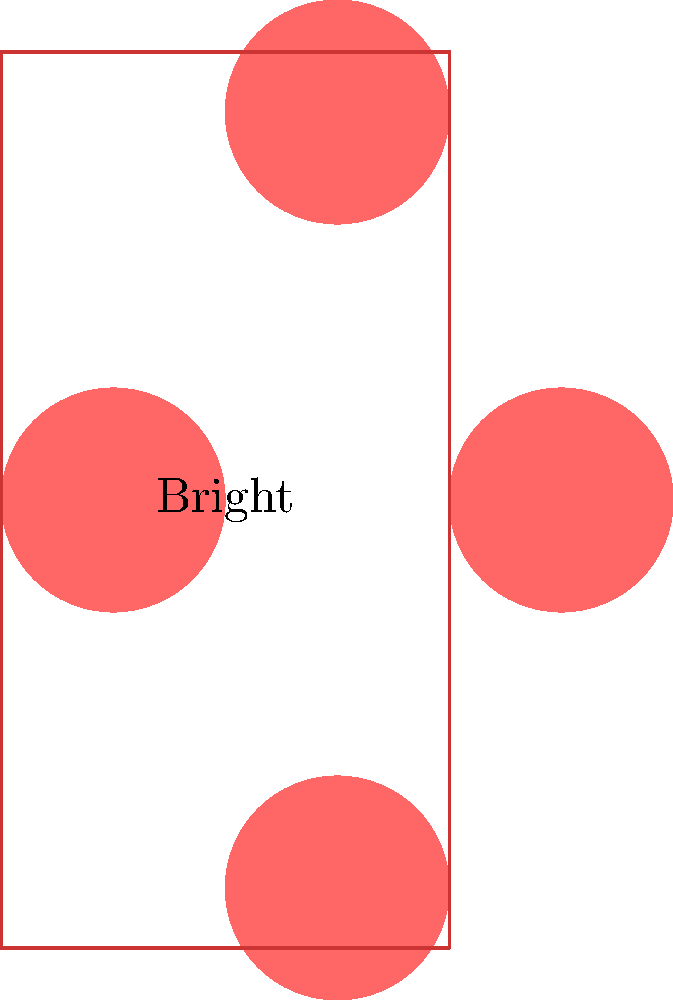In the image above, a heart shape is translated to create a border around a photo of Bright. If the original heart is centered at (0,0), what are the translation vectors needed to position the other three hearts? Let's approach this step-by-step:

1) We can see that there are four hearts in total, forming a diamond shape around the central square (which represents Bright's photo).

2) The original heart is at (0,0), so we need to find the vectors for the other three hearts.

3) For the heart on the right:
   - It's shifted 2 units to the right
   - Translation vector: $\vec{v_1} = (2,0)$

4) For the top heart:
   - It's shifted 1 unit to the right and $\sqrt{3}$ units up
   - Translation vector: $\vec{v_2} = (1,\sqrt{3})$

5) For the bottom heart:
   - It's shifted 1 unit to the right and $\sqrt{3}$ units down
   - Translation vector: $\vec{v_3} = (1,-\sqrt{3})$

6) We can simplify $\sqrt{3}$ to 1.732 for a decimal approximation.

Therefore, the three translation vectors are $(2,0)$, $(1,1.732)$, and $(1,-1.732)$.
Answer: $(2,0)$, $(1,1.732)$, $(1,-1.732)$ 